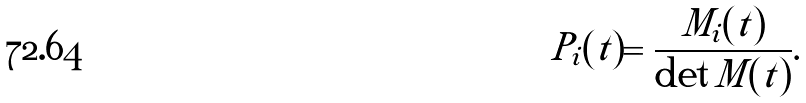Convert formula to latex. <formula><loc_0><loc_0><loc_500><loc_500>P _ { i } ( t ) = \frac { M _ { i } ( t ) } { \det M ( t ) } .</formula> 